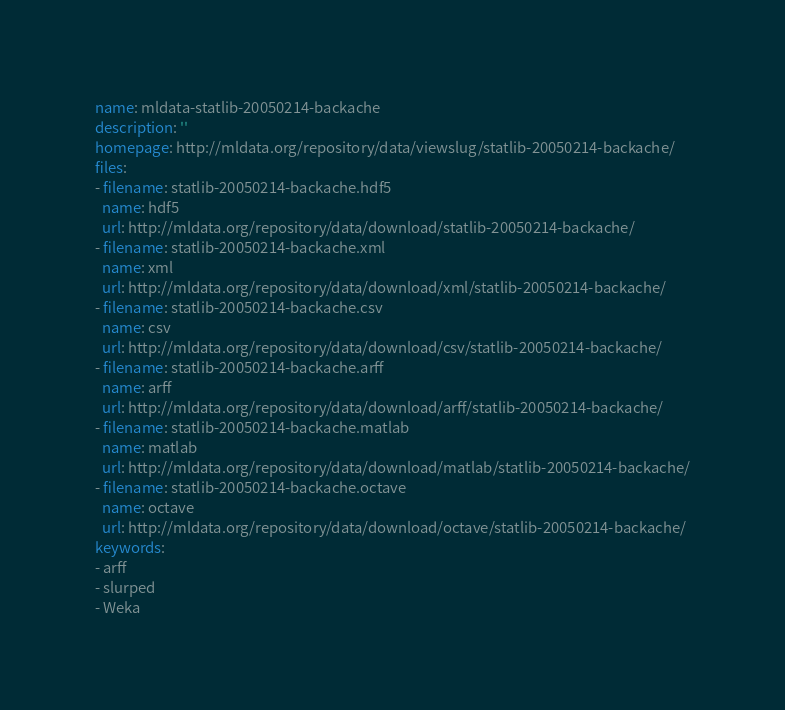Convert code to text. <code><loc_0><loc_0><loc_500><loc_500><_YAML_>name: mldata-statlib-20050214-backache
description: ''
homepage: http://mldata.org/repository/data/viewslug/statlib-20050214-backache/
files:
- filename: statlib-20050214-backache.hdf5
  name: hdf5
  url: http://mldata.org/repository/data/download/statlib-20050214-backache/
- filename: statlib-20050214-backache.xml
  name: xml
  url: http://mldata.org/repository/data/download/xml/statlib-20050214-backache/
- filename: statlib-20050214-backache.csv
  name: csv
  url: http://mldata.org/repository/data/download/csv/statlib-20050214-backache/
- filename: statlib-20050214-backache.arff
  name: arff
  url: http://mldata.org/repository/data/download/arff/statlib-20050214-backache/
- filename: statlib-20050214-backache.matlab
  name: matlab
  url: http://mldata.org/repository/data/download/matlab/statlib-20050214-backache/
- filename: statlib-20050214-backache.octave
  name: octave
  url: http://mldata.org/repository/data/download/octave/statlib-20050214-backache/
keywords:
- arff
- slurped
- Weka
</code> 